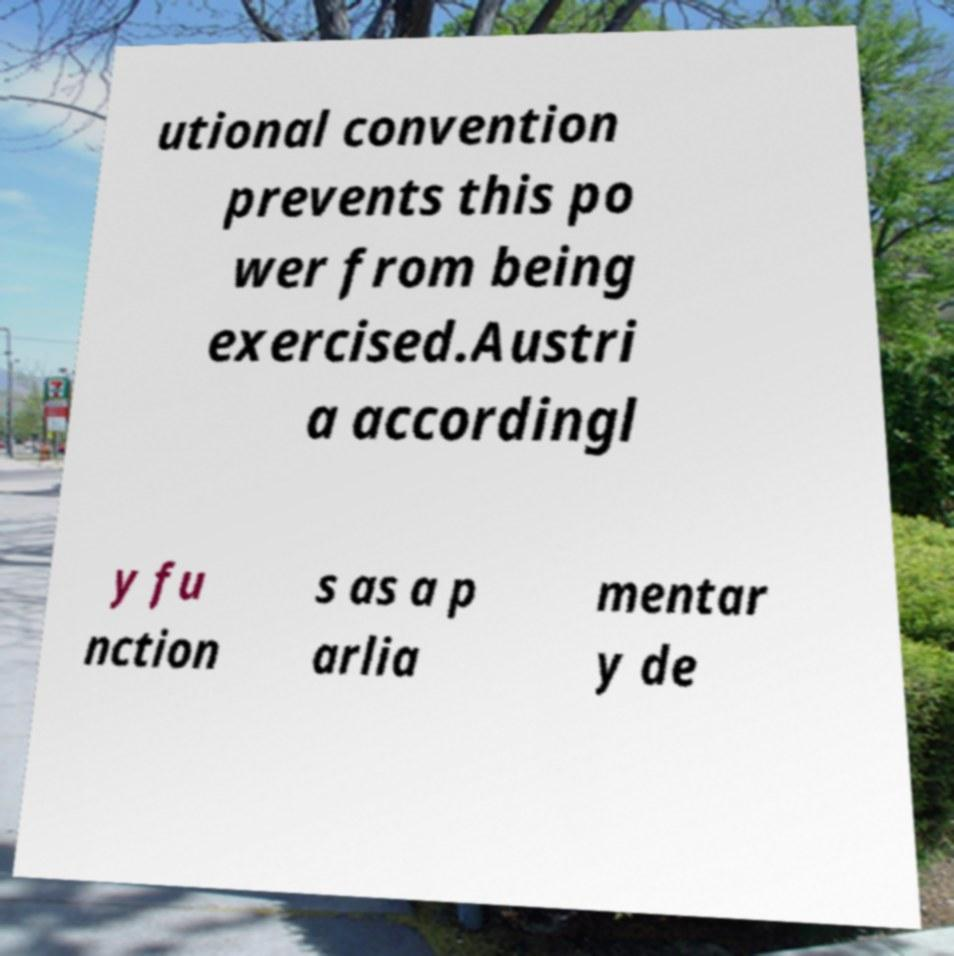I need the written content from this picture converted into text. Can you do that? utional convention prevents this po wer from being exercised.Austri a accordingl y fu nction s as a p arlia mentar y de 